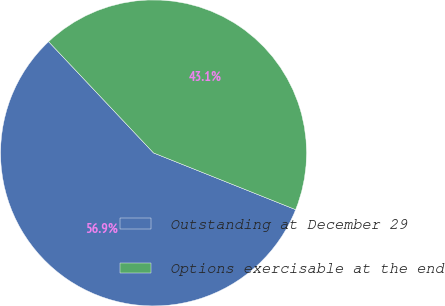<chart> <loc_0><loc_0><loc_500><loc_500><pie_chart><fcel>Outstanding at December 29<fcel>Options exercisable at the end<nl><fcel>56.92%<fcel>43.08%<nl></chart> 